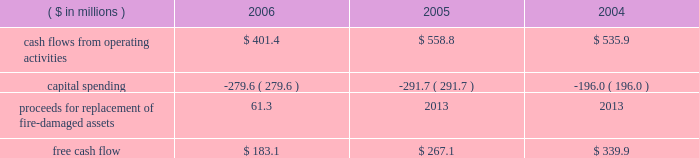Page 29 of 98 in connection with the internal revenue service 2019s ( irs ) examination of ball 2019s consolidated income tax returns for the tax years 2000 through 2004 , the irs has proposed to disallow ball 2019s deductions of interest expense incurred on loans under a company-owned life insurance plan that has been in place for more than 20 years .
Ball believes that its interest deductions will be sustained as filed and , therefore , no provision for loss has been recorded .
The total potential liability for the audit years 1999 through 2004 , unaudited year 2005 and an estimate of the impact on 2006 is approximately $ 31 million , excluding related interest .
The irs has withdrawn its proposed adjustments for any penalties .
See note 13 accompanying the consolidated financial statements within item 8 of this annual report .
Results of equity affiliates equity in the earnings of affiliates in 2006 is primarily attributable to our 50 percent ownership in packaging investments in the u.s .
And brazil .
Earnings in 2004 included the results of a minority-owned aerospace business , which was sold in october 2005 , and a $ 15.2 million loss representing ball 2019s share of a provision for doubtful accounts relating to its 35 percent interest in sanshui jfp ( discussed above in 201cmetal beverage packaging , europe/asia 201d ) .
After consideration of the prc loss , earnings were $ 14.7 million in 2006 compared to $ 15.5 million in 2005 and $ 15.8 million in 2004 .
Critical and significant accounting policies and new accounting pronouncements for information regarding the company 2019s critical and significant accounting policies , as well as recent accounting pronouncements , see note 1 to the consolidated financial statements within item 8 of this report .
Financial condition , liquidity and capital resources cash flows and capital expenditures cash flows from operating activities were $ 401.4 million in 2006 compared to $ 558.8 million in 2005 and $ 535.9 million in 2004 .
Management internally uses a free cash flow measure : ( 1 ) to evaluate the company 2019s operating results , ( 2 ) for planning purposes , ( 3 ) to evaluate strategic investments and ( 4 ) to evaluate the company 2019s ability to incur and service debt .
Free cash flow is not a defined term under u.s .
Generally accepted accounting principles , and it should not be inferred that the entire free cash flow amount is available for discretionary expenditures .
The company defines free cash flow as cash flow from operating activities less additions to property , plant and equipment ( capital spending ) .
Free cash flow is typically derived directly from the company 2019s cash flow statements ; however , it may be adjusted for items that affect comparability between periods .
An example of such an item included in 2006 is the property insurance proceeds for the replacement of the fire-damaged assets in our hassloch , germany , plant , which is included in capital spending amounts .
Based on this , our consolidated free cash flow is summarized as follows: .
Cash flows from operating activities in 2006 were negatively affected by higher cash pension funding and higher working capital levels compared to the prior year .
The higher working capital was a combination of higher than planned raw material inventory levels , higher income tax payments and higher accounts receivable balances , the latter resulting primarily from the repayment of a portion of the accounts receivable securitization program and late payments from customers in europe .
Management expects the increase in working capital to be temporary and that working capital levels will return to normal levels by the end of the first half of 2007. .
For 2006 , without the cash due to replacement of fire-damaged assets , what would free cash flow have been , in millions? 
Computations: (183.1 - 61.3)
Answer: 121.8. 